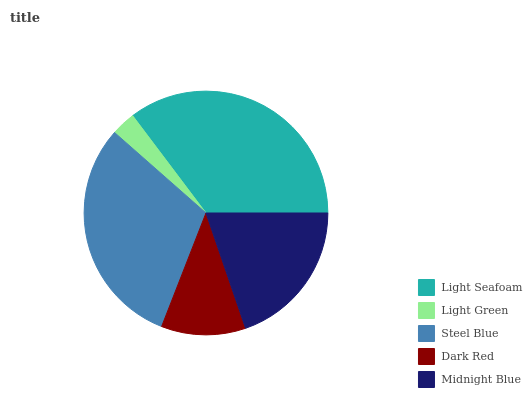Is Light Green the minimum?
Answer yes or no. Yes. Is Light Seafoam the maximum?
Answer yes or no. Yes. Is Steel Blue the minimum?
Answer yes or no. No. Is Steel Blue the maximum?
Answer yes or no. No. Is Steel Blue greater than Light Green?
Answer yes or no. Yes. Is Light Green less than Steel Blue?
Answer yes or no. Yes. Is Light Green greater than Steel Blue?
Answer yes or no. No. Is Steel Blue less than Light Green?
Answer yes or no. No. Is Midnight Blue the high median?
Answer yes or no. Yes. Is Midnight Blue the low median?
Answer yes or no. Yes. Is Light Seafoam the high median?
Answer yes or no. No. Is Dark Red the low median?
Answer yes or no. No. 